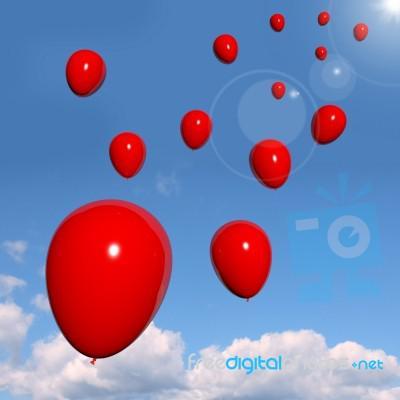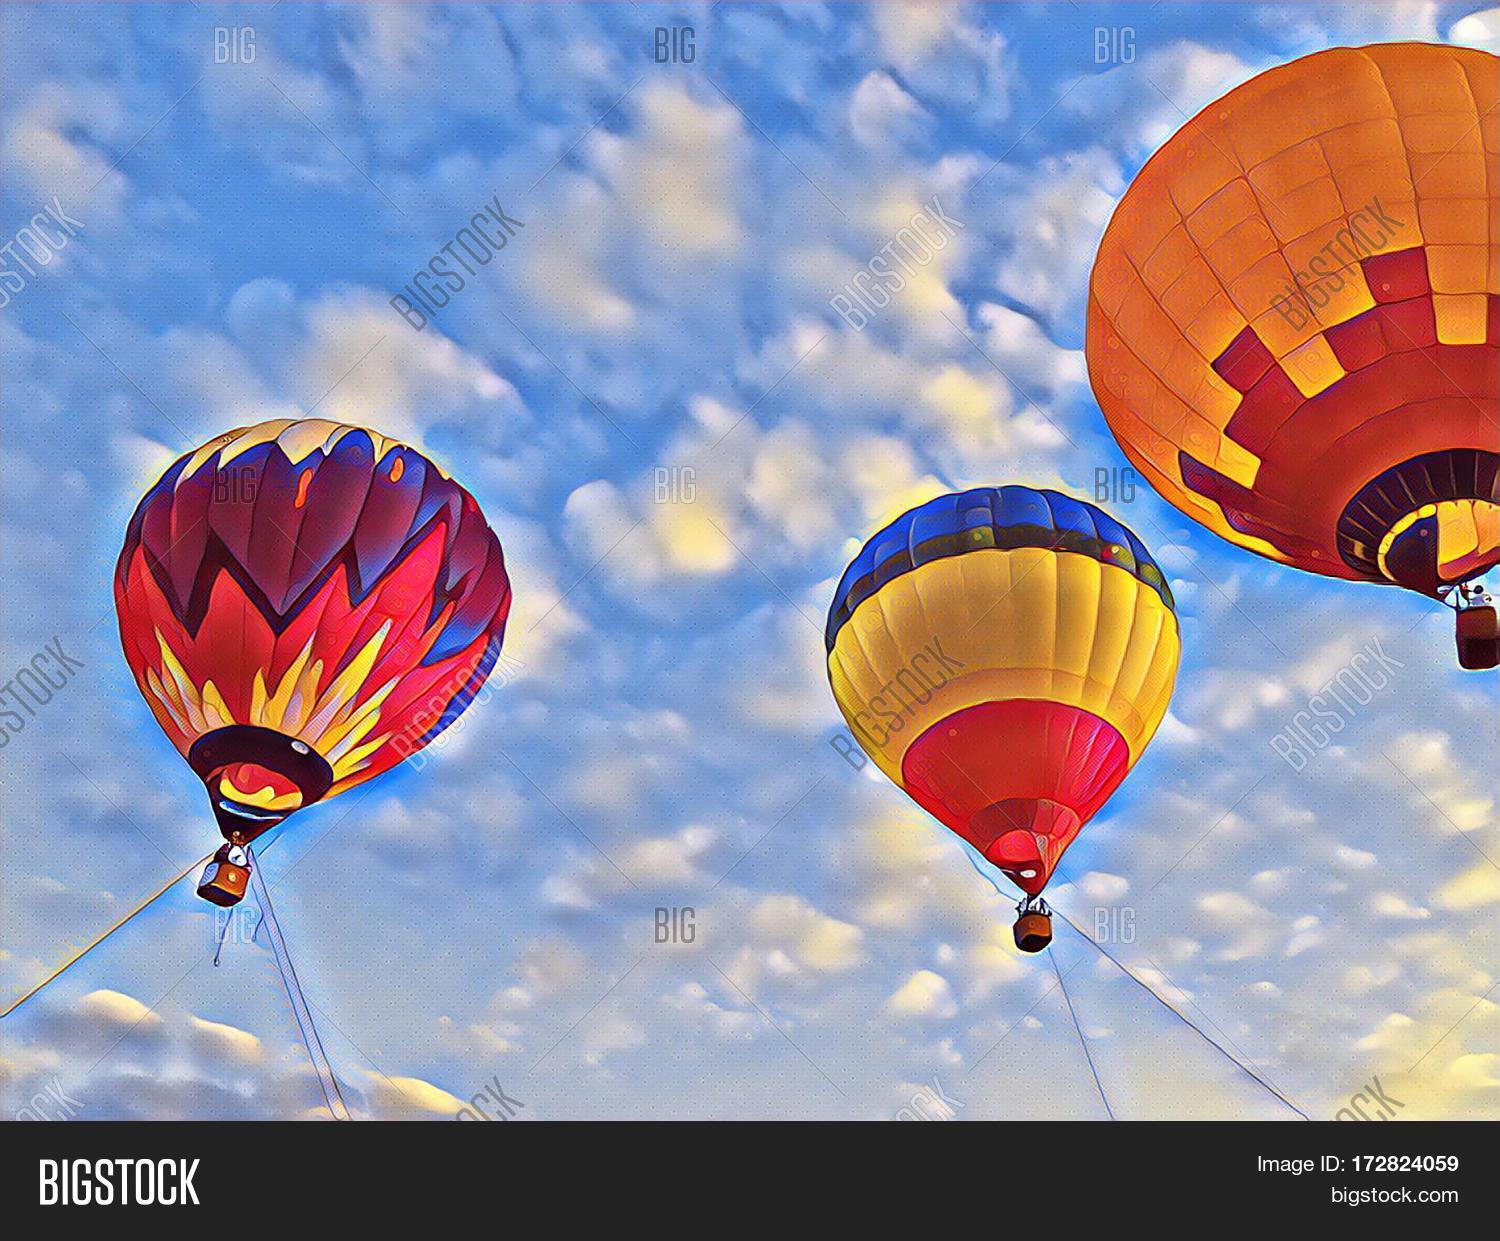The first image is the image on the left, the second image is the image on the right. Examine the images to the left and right. Is the description "There are balloons tied together." accurate? Answer yes or no. No. The first image is the image on the left, the second image is the image on the right. Assess this claim about the two images: "There are three hot air balloons.". Correct or not? Answer yes or no. Yes. 